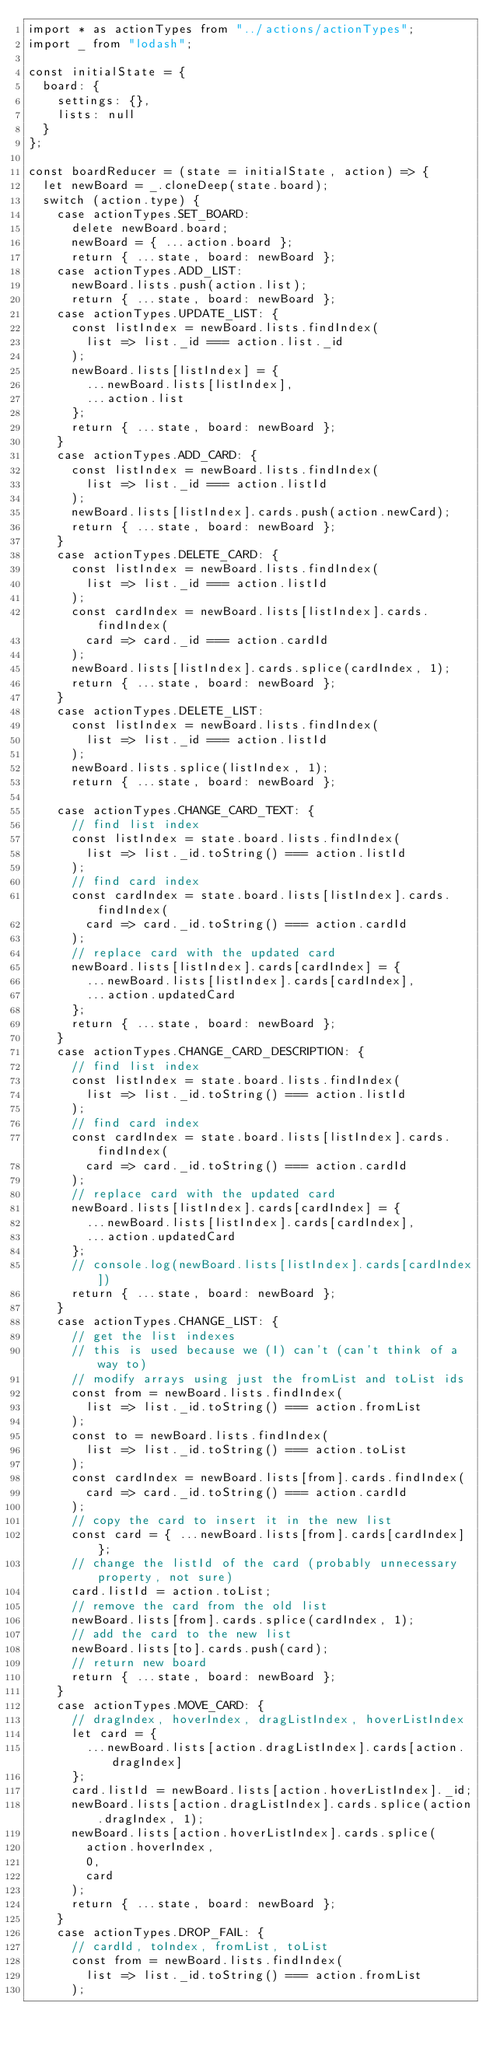Convert code to text. <code><loc_0><loc_0><loc_500><loc_500><_JavaScript_>import * as actionTypes from "../actions/actionTypes";
import _ from "lodash";

const initialState = {
  board: {
    settings: {},
    lists: null
  }
};

const boardReducer = (state = initialState, action) => {
  let newBoard = _.cloneDeep(state.board);
  switch (action.type) {
    case actionTypes.SET_BOARD:
      delete newBoard.board;
      newBoard = { ...action.board };
      return { ...state, board: newBoard };
    case actionTypes.ADD_LIST:
      newBoard.lists.push(action.list);
      return { ...state, board: newBoard };
    case actionTypes.UPDATE_LIST: {
      const listIndex = newBoard.lists.findIndex(
        list => list._id === action.list._id
      );
      newBoard.lists[listIndex] = {
        ...newBoard.lists[listIndex],
        ...action.list
      };
      return { ...state, board: newBoard };
    }
    case actionTypes.ADD_CARD: {
      const listIndex = newBoard.lists.findIndex(
        list => list._id === action.listId
      );
      newBoard.lists[listIndex].cards.push(action.newCard);
      return { ...state, board: newBoard };
    }
    case actionTypes.DELETE_CARD: {
      const listIndex = newBoard.lists.findIndex(
        list => list._id === action.listId
      );
      const cardIndex = newBoard.lists[listIndex].cards.findIndex(
        card => card._id === action.cardId
      );
      newBoard.lists[listIndex].cards.splice(cardIndex, 1);
      return { ...state, board: newBoard };
    }
    case actionTypes.DELETE_LIST:
      const listIndex = newBoard.lists.findIndex(
        list => list._id === action.listId
      );
      newBoard.lists.splice(listIndex, 1);
      return { ...state, board: newBoard };

    case actionTypes.CHANGE_CARD_TEXT: {
      // find list index
      const listIndex = state.board.lists.findIndex(
        list => list._id.toString() === action.listId
      );
      // find card index
      const cardIndex = state.board.lists[listIndex].cards.findIndex(
        card => card._id.toString() === action.cardId
      );
      // replace card with the updated card
      newBoard.lists[listIndex].cards[cardIndex] = {
        ...newBoard.lists[listIndex].cards[cardIndex],
        ...action.updatedCard
      };
      return { ...state, board: newBoard };
    }
    case actionTypes.CHANGE_CARD_DESCRIPTION: {
      // find list index
      const listIndex = state.board.lists.findIndex(
        list => list._id.toString() === action.listId
      );
      // find card index
      const cardIndex = state.board.lists[listIndex].cards.findIndex(
        card => card._id.toString() === action.cardId
      );
      // replace card with the updated card
      newBoard.lists[listIndex].cards[cardIndex] = {
        ...newBoard.lists[listIndex].cards[cardIndex],
        ...action.updatedCard
      };
      // console.log(newBoard.lists[listIndex].cards[cardIndex])
      return { ...state, board: newBoard };
    }
    case actionTypes.CHANGE_LIST: {
      // get the list indexes
      // this is used because we (I) can't (can't think of a way to)
      // modify arrays using just the fromList and toList ids
      const from = newBoard.lists.findIndex(
        list => list._id.toString() === action.fromList
      );
      const to = newBoard.lists.findIndex(
        list => list._id.toString() === action.toList
      );
      const cardIndex = newBoard.lists[from].cards.findIndex(
        card => card._id.toString() === action.cardId
      );
      // copy the card to insert it in the new list
      const card = { ...newBoard.lists[from].cards[cardIndex] };
      // change the listId of the card (probably unnecessary property, not sure)
      card.listId = action.toList;
      // remove the card from the old list
      newBoard.lists[from].cards.splice(cardIndex, 1);
      // add the card to the new list
      newBoard.lists[to].cards.push(card);
      // return new board
      return { ...state, board: newBoard };
    }
    case actionTypes.MOVE_CARD: {
      // dragIndex, hoverIndex, dragListIndex, hoverListIndex
      let card = {
        ...newBoard.lists[action.dragListIndex].cards[action.dragIndex]
      };
      card.listId = newBoard.lists[action.hoverListIndex]._id;
      newBoard.lists[action.dragListIndex].cards.splice(action.dragIndex, 1);
      newBoard.lists[action.hoverListIndex].cards.splice(
        action.hoverIndex,
        0,
        card
      );
      return { ...state, board: newBoard };
    }
    case actionTypes.DROP_FAIL: {
      // cardId, toIndex, fromList, toList
      const from = newBoard.lists.findIndex(
        list => list._id.toString() === action.fromList
      );</code> 